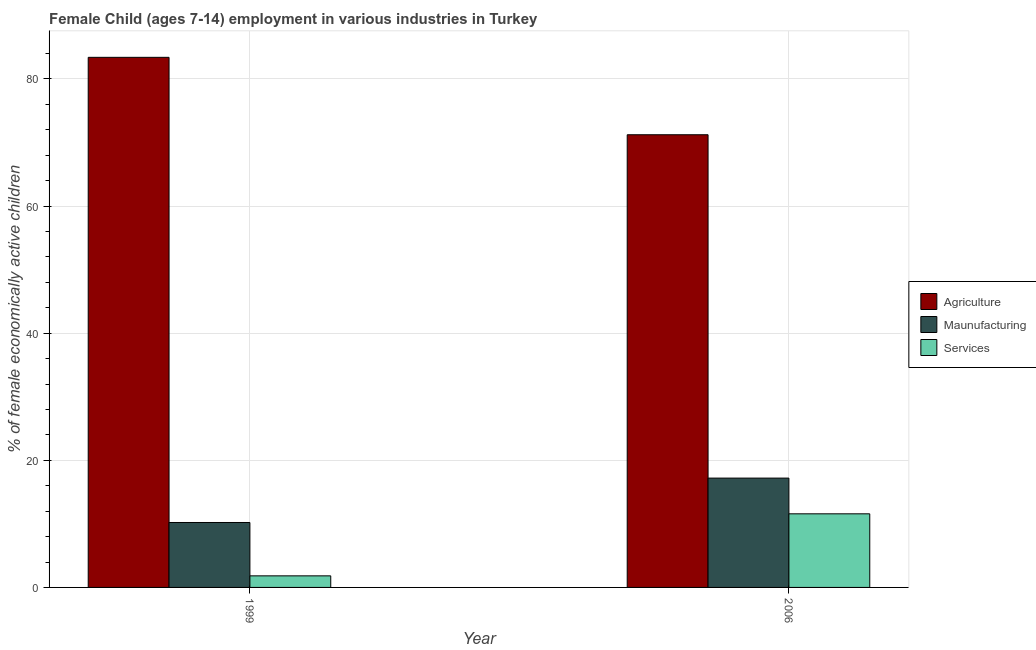How many different coloured bars are there?
Give a very brief answer. 3. How many groups of bars are there?
Your response must be concise. 2. How many bars are there on the 2nd tick from the left?
Keep it short and to the point. 3. How many bars are there on the 1st tick from the right?
Keep it short and to the point. 3. What is the label of the 2nd group of bars from the left?
Your answer should be compact. 2006. In how many cases, is the number of bars for a given year not equal to the number of legend labels?
Offer a very short reply. 0. What is the percentage of economically active children in manufacturing in 2006?
Your response must be concise. 17.2. Across all years, what is the maximum percentage of economically active children in manufacturing?
Make the answer very short. 17.2. Across all years, what is the minimum percentage of economically active children in agriculture?
Ensure brevity in your answer.  71.22. What is the total percentage of economically active children in services in the graph?
Make the answer very short. 13.4. What is the difference between the percentage of economically active children in services in 1999 and that in 2006?
Provide a short and direct response. -9.76. What is the difference between the percentage of economically active children in manufacturing in 1999 and the percentage of economically active children in services in 2006?
Your answer should be compact. -6.98. What is the average percentage of economically active children in manufacturing per year?
Give a very brief answer. 13.71. In how many years, is the percentage of economically active children in services greater than 28 %?
Your answer should be very brief. 0. What is the ratio of the percentage of economically active children in agriculture in 1999 to that in 2006?
Provide a succinct answer. 1.17. In how many years, is the percentage of economically active children in services greater than the average percentage of economically active children in services taken over all years?
Your answer should be compact. 1. What does the 1st bar from the left in 2006 represents?
Provide a succinct answer. Agriculture. What does the 2nd bar from the right in 1999 represents?
Give a very brief answer. Maunufacturing. How many bars are there?
Offer a terse response. 6. How many years are there in the graph?
Your response must be concise. 2. Are the values on the major ticks of Y-axis written in scientific E-notation?
Provide a succinct answer. No. Does the graph contain grids?
Provide a short and direct response. Yes. How are the legend labels stacked?
Give a very brief answer. Vertical. What is the title of the graph?
Your answer should be very brief. Female Child (ages 7-14) employment in various industries in Turkey. What is the label or title of the X-axis?
Offer a terse response. Year. What is the label or title of the Y-axis?
Offer a terse response. % of female economically active children. What is the % of female economically active children in Agriculture in 1999?
Your response must be concise. 83.4. What is the % of female economically active children in Maunufacturing in 1999?
Your answer should be very brief. 10.22. What is the % of female economically active children of Services in 1999?
Keep it short and to the point. 1.82. What is the % of female economically active children of Agriculture in 2006?
Your answer should be compact. 71.22. What is the % of female economically active children in Services in 2006?
Give a very brief answer. 11.58. Across all years, what is the maximum % of female economically active children of Agriculture?
Your answer should be compact. 83.4. Across all years, what is the maximum % of female economically active children of Maunufacturing?
Offer a very short reply. 17.2. Across all years, what is the maximum % of female economically active children of Services?
Your answer should be compact. 11.58. Across all years, what is the minimum % of female economically active children in Agriculture?
Offer a terse response. 71.22. Across all years, what is the minimum % of female economically active children of Maunufacturing?
Your response must be concise. 10.22. Across all years, what is the minimum % of female economically active children in Services?
Your response must be concise. 1.82. What is the total % of female economically active children of Agriculture in the graph?
Offer a very short reply. 154.62. What is the total % of female economically active children of Maunufacturing in the graph?
Offer a very short reply. 27.42. What is the total % of female economically active children in Services in the graph?
Provide a succinct answer. 13.4. What is the difference between the % of female economically active children in Agriculture in 1999 and that in 2006?
Give a very brief answer. 12.18. What is the difference between the % of female economically active children of Maunufacturing in 1999 and that in 2006?
Provide a short and direct response. -6.98. What is the difference between the % of female economically active children in Services in 1999 and that in 2006?
Offer a very short reply. -9.76. What is the difference between the % of female economically active children of Agriculture in 1999 and the % of female economically active children of Maunufacturing in 2006?
Give a very brief answer. 66.2. What is the difference between the % of female economically active children of Agriculture in 1999 and the % of female economically active children of Services in 2006?
Provide a short and direct response. 71.82. What is the difference between the % of female economically active children in Maunufacturing in 1999 and the % of female economically active children in Services in 2006?
Offer a terse response. -1.36. What is the average % of female economically active children of Agriculture per year?
Offer a terse response. 77.31. What is the average % of female economically active children in Maunufacturing per year?
Provide a succinct answer. 13.71. What is the average % of female economically active children of Services per year?
Give a very brief answer. 6.7. In the year 1999, what is the difference between the % of female economically active children in Agriculture and % of female economically active children in Maunufacturing?
Keep it short and to the point. 73.18. In the year 1999, what is the difference between the % of female economically active children of Agriculture and % of female economically active children of Services?
Make the answer very short. 81.58. In the year 1999, what is the difference between the % of female economically active children in Maunufacturing and % of female economically active children in Services?
Ensure brevity in your answer.  8.39. In the year 2006, what is the difference between the % of female economically active children in Agriculture and % of female economically active children in Maunufacturing?
Your answer should be compact. 54.02. In the year 2006, what is the difference between the % of female economically active children of Agriculture and % of female economically active children of Services?
Provide a short and direct response. 59.64. In the year 2006, what is the difference between the % of female economically active children of Maunufacturing and % of female economically active children of Services?
Offer a terse response. 5.62. What is the ratio of the % of female economically active children in Agriculture in 1999 to that in 2006?
Keep it short and to the point. 1.17. What is the ratio of the % of female economically active children in Maunufacturing in 1999 to that in 2006?
Provide a succinct answer. 0.59. What is the ratio of the % of female economically active children in Services in 1999 to that in 2006?
Ensure brevity in your answer.  0.16. What is the difference between the highest and the second highest % of female economically active children of Agriculture?
Provide a succinct answer. 12.18. What is the difference between the highest and the second highest % of female economically active children of Maunufacturing?
Ensure brevity in your answer.  6.98. What is the difference between the highest and the second highest % of female economically active children of Services?
Give a very brief answer. 9.76. What is the difference between the highest and the lowest % of female economically active children of Agriculture?
Offer a terse response. 12.18. What is the difference between the highest and the lowest % of female economically active children in Maunufacturing?
Keep it short and to the point. 6.98. What is the difference between the highest and the lowest % of female economically active children of Services?
Provide a succinct answer. 9.76. 